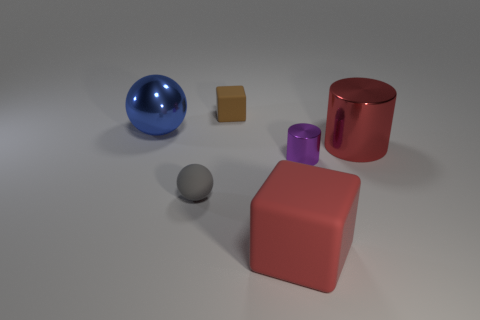There is a rubber cube behind the rubber block that is in front of the big blue object; what size is it?
Offer a very short reply. Small. Are any tiny gray rubber spheres visible?
Provide a short and direct response. Yes. There is a block that is behind the tiny gray matte object; what number of things are in front of it?
Provide a succinct answer. 5. The metallic thing that is on the left side of the tiny purple metallic thing has what shape?
Give a very brief answer. Sphere. What is the red thing that is in front of the tiny object in front of the metallic cylinder that is in front of the red cylinder made of?
Provide a short and direct response. Rubber. How many other things are there of the same size as the red cylinder?
Make the answer very short. 2. There is a tiny brown object that is the same shape as the large matte thing; what material is it?
Your answer should be very brief. Rubber. What color is the tiny ball?
Offer a very short reply. Gray. There is a block that is behind the small thing that is right of the big red matte cube; what color is it?
Your response must be concise. Brown. There is a tiny ball; is it the same color as the block that is in front of the large red cylinder?
Keep it short and to the point. No. 